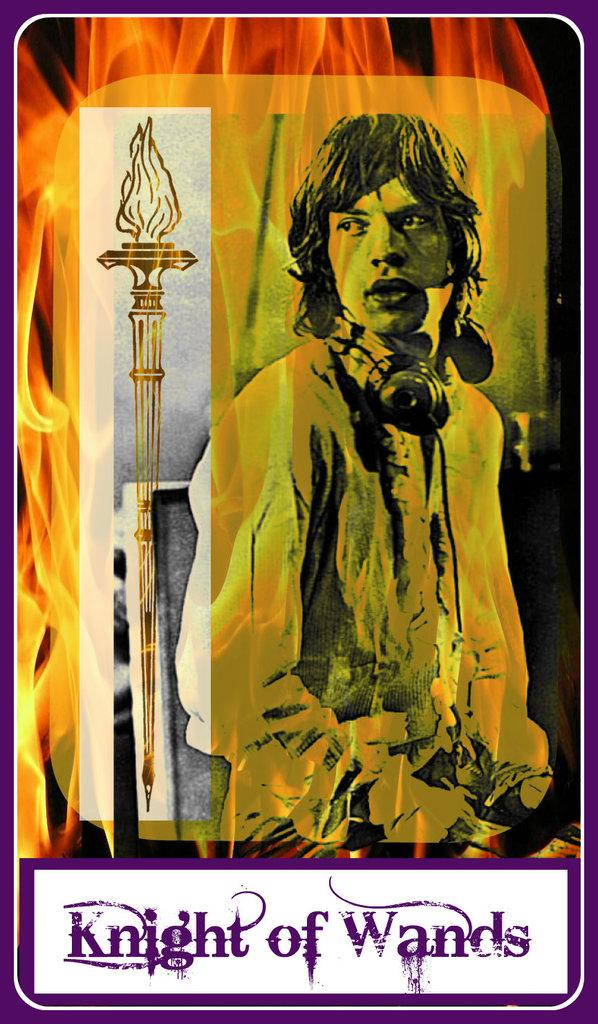<image>
Summarize the visual content of the image. A card with a man wearing head phones has the words "Knight of Wands" at the bottom. 